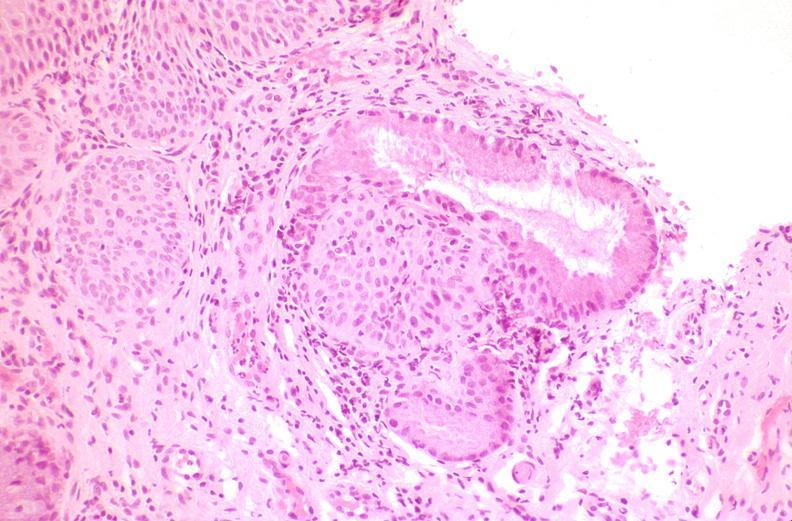where is this from?
Answer the question using a single word or phrase. Female reproductive system 